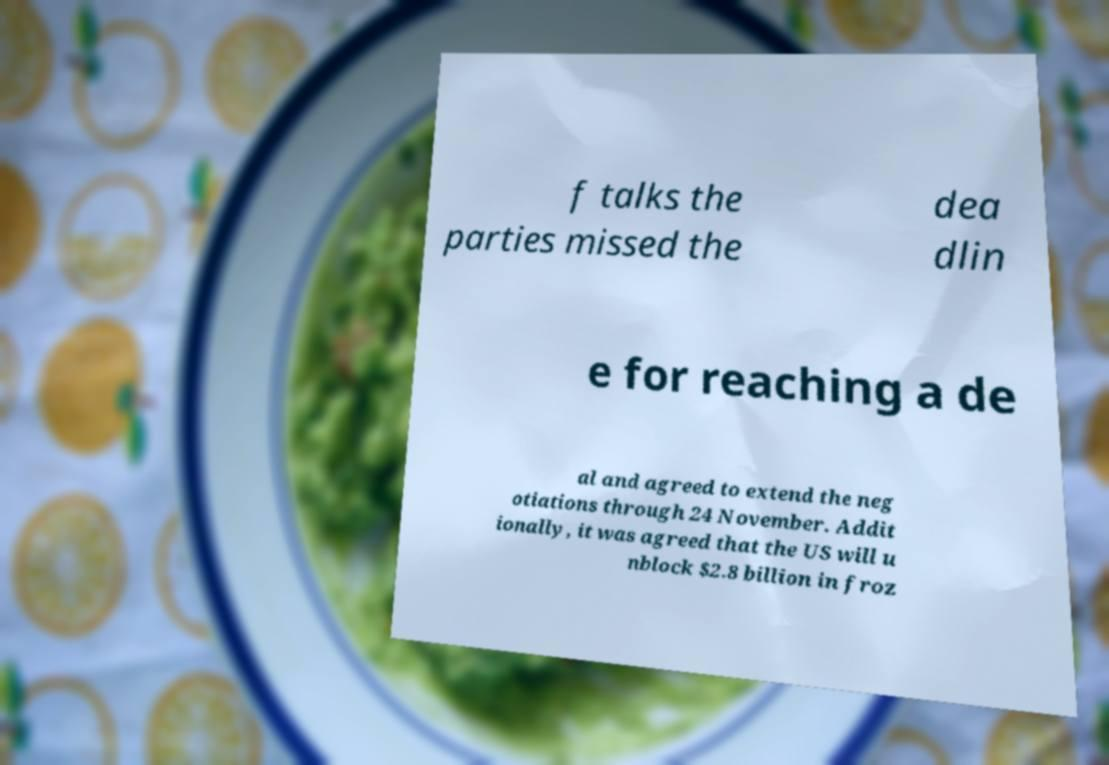I need the written content from this picture converted into text. Can you do that? f talks the parties missed the dea dlin e for reaching a de al and agreed to extend the neg otiations through 24 November. Addit ionally, it was agreed that the US will u nblock $2.8 billion in froz 